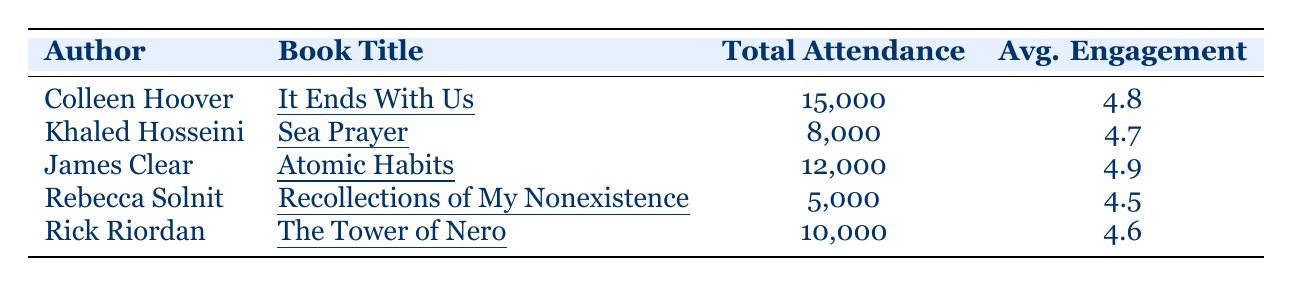What is the total attendance for Colleen Hoover's book tour? The table shows that Colleen Hoover had a total attendance of 15,000 for her book tour.
Answer: 15,000 Which author had the highest average engagement rating? Colleen Hoover has the highest average engagement rating of 4.8 according to the table.
Answer: Colleen Hoover How many tour cities did James Clear visit? James Clear visited 5 tour cities as listed in the table.
Answer: 5 What is the average attendance for the authors listed in the table? The total attendance for all authors is 15,000 + 8,000 + 12,000 + 5,000 + 10,000 = 50,000. There are 5 authors, so the average attendance is 50,000 / 5 = 10,000.
Answer: 10,000 Did Rick Riordan have a lower average engagement rating than Rebecca Solnit? Rick Riordan's average engagement rating is 4.6, while Rebecca Solnit's is 4.5. Therefore, Rick Riordan had a higher average engagement rating.
Answer: No How does the attendance of Khaled Hosseini compare to that of Rick Riordan? Khaled Hosseini had a total attendance of 8,000 and Rick Riordan had 10,000, making Rick Riordan's attendance higher by 2,000.
Answer: Rick Riordan had higher attendance by 2,000 Calculate the difference in total attendance between the author with the highest attendance and the author with the lowest attendance. The highest total attendance is from Colleen Hoover with 15,000, and the lowest is from Rebecca Solnit with 5,000. The difference is 15,000 - 5,000 = 10,000.
Answer: 10,000 What is the total attendance of authors whose books have an average engagement rating above 4.6? James Clear (4.9) and Colleen Hoover (4.8) have average engagement ratings above 4.6. Their total attendance is 12,000 + 15,000 = 27,000.
Answer: 27,000 Which book had the lowest total attendance? The table indicates that "Recollections of My Nonexistence" by Rebecca Solnit had the lowest total attendance of 5,000.
Answer: Recollections of My Nonexistence Is it true that all authors had an average engagement rating of 4.5 or higher? Yes, all authors have engagement ratings of 4.5 or higher as indicated in the table.
Answer: Yes 